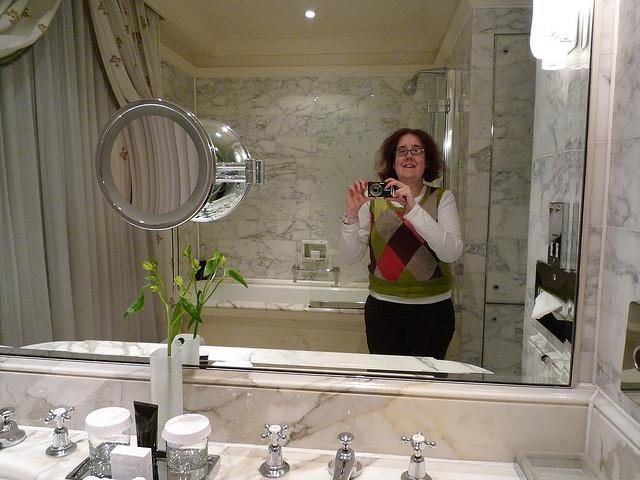What type of shower head is in the background?
Indicate the correct response and explain using: 'Answer: answer
Rationale: rationale.'
Options: Removable, wall mount, rainfall, underwater. Answer: wall mount.
Rationale: The shower head is on the wall. 